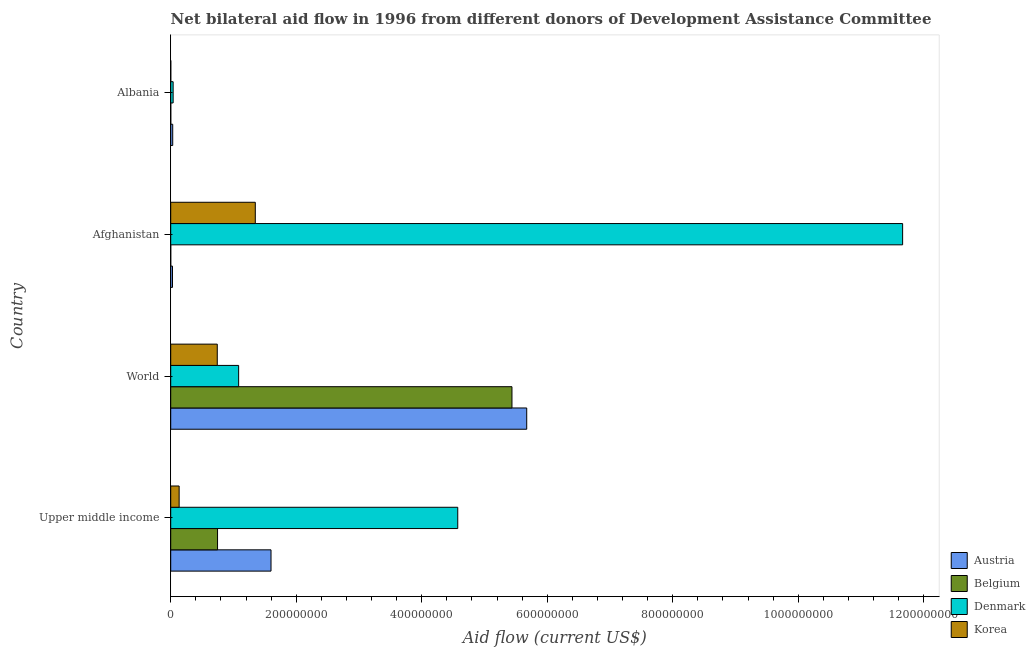How many groups of bars are there?
Give a very brief answer. 4. How many bars are there on the 1st tick from the top?
Your answer should be very brief. 4. What is the label of the 1st group of bars from the top?
Your response must be concise. Albania. What is the amount of aid given by belgium in Albania?
Ensure brevity in your answer.  8.00e+04. Across all countries, what is the maximum amount of aid given by belgium?
Your answer should be compact. 5.44e+08. Across all countries, what is the minimum amount of aid given by denmark?
Your answer should be very brief. 3.85e+06. In which country was the amount of aid given by denmark maximum?
Provide a succinct answer. Afghanistan. In which country was the amount of aid given by belgium minimum?
Your response must be concise. Afghanistan. What is the total amount of aid given by austria in the graph?
Your response must be concise. 7.33e+08. What is the difference between the amount of aid given by belgium in Afghanistan and that in Upper middle income?
Offer a terse response. -7.46e+07. What is the difference between the amount of aid given by denmark in World and the amount of aid given by korea in Afghanistan?
Provide a short and direct response. -2.66e+07. What is the average amount of aid given by belgium per country?
Provide a short and direct response. 1.55e+08. What is the difference between the amount of aid given by denmark and amount of aid given by belgium in Albania?
Offer a very short reply. 3.77e+06. In how many countries, is the amount of aid given by belgium greater than 160000000 US$?
Provide a short and direct response. 1. What is the ratio of the amount of aid given by austria in Albania to that in World?
Your answer should be compact. 0.01. What is the difference between the highest and the second highest amount of aid given by belgium?
Provide a short and direct response. 4.69e+08. What is the difference between the highest and the lowest amount of aid given by austria?
Ensure brevity in your answer.  5.64e+08. In how many countries, is the amount of aid given by denmark greater than the average amount of aid given by denmark taken over all countries?
Provide a succinct answer. 2. Is it the case that in every country, the sum of the amount of aid given by austria and amount of aid given by belgium is greater than the amount of aid given by denmark?
Your answer should be compact. No. Are all the bars in the graph horizontal?
Ensure brevity in your answer.  Yes. Are the values on the major ticks of X-axis written in scientific E-notation?
Keep it short and to the point. No. Does the graph contain any zero values?
Give a very brief answer. No. Does the graph contain grids?
Make the answer very short. No. Where does the legend appear in the graph?
Your response must be concise. Bottom right. What is the title of the graph?
Ensure brevity in your answer.  Net bilateral aid flow in 1996 from different donors of Development Assistance Committee. Does "Norway" appear as one of the legend labels in the graph?
Offer a terse response. No. What is the label or title of the X-axis?
Offer a terse response. Aid flow (current US$). What is the label or title of the Y-axis?
Provide a succinct answer. Country. What is the Aid flow (current US$) of Austria in Upper middle income?
Offer a terse response. 1.60e+08. What is the Aid flow (current US$) in Belgium in Upper middle income?
Keep it short and to the point. 7.46e+07. What is the Aid flow (current US$) of Denmark in Upper middle income?
Ensure brevity in your answer.  4.57e+08. What is the Aid flow (current US$) of Korea in Upper middle income?
Make the answer very short. 1.34e+07. What is the Aid flow (current US$) of Austria in World?
Offer a very short reply. 5.67e+08. What is the Aid flow (current US$) of Belgium in World?
Your answer should be very brief. 5.44e+08. What is the Aid flow (current US$) in Denmark in World?
Offer a terse response. 1.08e+08. What is the Aid flow (current US$) of Korea in World?
Keep it short and to the point. 7.42e+07. What is the Aid flow (current US$) of Austria in Afghanistan?
Provide a succinct answer. 2.85e+06. What is the Aid flow (current US$) of Denmark in Afghanistan?
Your response must be concise. 1.17e+09. What is the Aid flow (current US$) of Korea in Afghanistan?
Provide a succinct answer. 1.35e+08. What is the Aid flow (current US$) in Austria in Albania?
Offer a terse response. 3.19e+06. What is the Aid flow (current US$) of Belgium in Albania?
Offer a terse response. 8.00e+04. What is the Aid flow (current US$) in Denmark in Albania?
Your answer should be very brief. 3.85e+06. Across all countries, what is the maximum Aid flow (current US$) in Austria?
Ensure brevity in your answer.  5.67e+08. Across all countries, what is the maximum Aid flow (current US$) in Belgium?
Offer a terse response. 5.44e+08. Across all countries, what is the maximum Aid flow (current US$) in Denmark?
Your answer should be very brief. 1.17e+09. Across all countries, what is the maximum Aid flow (current US$) in Korea?
Provide a succinct answer. 1.35e+08. Across all countries, what is the minimum Aid flow (current US$) in Austria?
Offer a very short reply. 2.85e+06. Across all countries, what is the minimum Aid flow (current US$) in Belgium?
Provide a short and direct response. 10000. Across all countries, what is the minimum Aid flow (current US$) in Denmark?
Your answer should be compact. 3.85e+06. What is the total Aid flow (current US$) in Austria in the graph?
Provide a short and direct response. 7.33e+08. What is the total Aid flow (current US$) of Belgium in the graph?
Make the answer very short. 6.19e+08. What is the total Aid flow (current US$) in Denmark in the graph?
Offer a terse response. 1.74e+09. What is the total Aid flow (current US$) in Korea in the graph?
Your answer should be compact. 2.23e+08. What is the difference between the Aid flow (current US$) in Austria in Upper middle income and that in World?
Your answer should be compact. -4.08e+08. What is the difference between the Aid flow (current US$) in Belgium in Upper middle income and that in World?
Make the answer very short. -4.69e+08. What is the difference between the Aid flow (current US$) of Denmark in Upper middle income and that in World?
Your answer should be compact. 3.49e+08. What is the difference between the Aid flow (current US$) in Korea in Upper middle income and that in World?
Keep it short and to the point. -6.08e+07. What is the difference between the Aid flow (current US$) in Austria in Upper middle income and that in Afghanistan?
Your answer should be compact. 1.57e+08. What is the difference between the Aid flow (current US$) of Belgium in Upper middle income and that in Afghanistan?
Provide a short and direct response. 7.46e+07. What is the difference between the Aid flow (current US$) of Denmark in Upper middle income and that in Afghanistan?
Provide a short and direct response. -7.09e+08. What is the difference between the Aid flow (current US$) of Korea in Upper middle income and that in Afghanistan?
Keep it short and to the point. -1.21e+08. What is the difference between the Aid flow (current US$) of Austria in Upper middle income and that in Albania?
Provide a short and direct response. 1.57e+08. What is the difference between the Aid flow (current US$) in Belgium in Upper middle income and that in Albania?
Give a very brief answer. 7.46e+07. What is the difference between the Aid flow (current US$) in Denmark in Upper middle income and that in Albania?
Offer a very short reply. 4.54e+08. What is the difference between the Aid flow (current US$) of Korea in Upper middle income and that in Albania?
Your answer should be very brief. 1.33e+07. What is the difference between the Aid flow (current US$) in Austria in World and that in Afghanistan?
Make the answer very short. 5.64e+08. What is the difference between the Aid flow (current US$) of Belgium in World and that in Afghanistan?
Offer a terse response. 5.44e+08. What is the difference between the Aid flow (current US$) of Denmark in World and that in Afghanistan?
Your response must be concise. -1.06e+09. What is the difference between the Aid flow (current US$) in Korea in World and that in Afghanistan?
Provide a succinct answer. -6.06e+07. What is the difference between the Aid flow (current US$) in Austria in World and that in Albania?
Offer a terse response. 5.64e+08. What is the difference between the Aid flow (current US$) of Belgium in World and that in Albania?
Offer a very short reply. 5.44e+08. What is the difference between the Aid flow (current US$) in Denmark in World and that in Albania?
Give a very brief answer. 1.04e+08. What is the difference between the Aid flow (current US$) in Korea in World and that in Albania?
Make the answer very short. 7.41e+07. What is the difference between the Aid flow (current US$) in Austria in Afghanistan and that in Albania?
Your answer should be very brief. -3.40e+05. What is the difference between the Aid flow (current US$) of Belgium in Afghanistan and that in Albania?
Your answer should be very brief. -7.00e+04. What is the difference between the Aid flow (current US$) of Denmark in Afghanistan and that in Albania?
Give a very brief answer. 1.16e+09. What is the difference between the Aid flow (current US$) of Korea in Afghanistan and that in Albania?
Make the answer very short. 1.35e+08. What is the difference between the Aid flow (current US$) in Austria in Upper middle income and the Aid flow (current US$) in Belgium in World?
Give a very brief answer. -3.84e+08. What is the difference between the Aid flow (current US$) of Austria in Upper middle income and the Aid flow (current US$) of Denmark in World?
Make the answer very short. 5.16e+07. What is the difference between the Aid flow (current US$) of Austria in Upper middle income and the Aid flow (current US$) of Korea in World?
Your answer should be very brief. 8.56e+07. What is the difference between the Aid flow (current US$) in Belgium in Upper middle income and the Aid flow (current US$) in Denmark in World?
Keep it short and to the point. -3.36e+07. What is the difference between the Aid flow (current US$) of Denmark in Upper middle income and the Aid flow (current US$) of Korea in World?
Offer a very short reply. 3.83e+08. What is the difference between the Aid flow (current US$) in Austria in Upper middle income and the Aid flow (current US$) in Belgium in Afghanistan?
Your answer should be very brief. 1.60e+08. What is the difference between the Aid flow (current US$) in Austria in Upper middle income and the Aid flow (current US$) in Denmark in Afghanistan?
Provide a short and direct response. -1.01e+09. What is the difference between the Aid flow (current US$) in Austria in Upper middle income and the Aid flow (current US$) in Korea in Afghanistan?
Your answer should be compact. 2.50e+07. What is the difference between the Aid flow (current US$) of Belgium in Upper middle income and the Aid flow (current US$) of Denmark in Afghanistan?
Your answer should be very brief. -1.09e+09. What is the difference between the Aid flow (current US$) of Belgium in Upper middle income and the Aid flow (current US$) of Korea in Afghanistan?
Provide a short and direct response. -6.02e+07. What is the difference between the Aid flow (current US$) of Denmark in Upper middle income and the Aid flow (current US$) of Korea in Afghanistan?
Give a very brief answer. 3.23e+08. What is the difference between the Aid flow (current US$) of Austria in Upper middle income and the Aid flow (current US$) of Belgium in Albania?
Provide a succinct answer. 1.60e+08. What is the difference between the Aid flow (current US$) of Austria in Upper middle income and the Aid flow (current US$) of Denmark in Albania?
Make the answer very short. 1.56e+08. What is the difference between the Aid flow (current US$) of Austria in Upper middle income and the Aid flow (current US$) of Korea in Albania?
Offer a terse response. 1.60e+08. What is the difference between the Aid flow (current US$) of Belgium in Upper middle income and the Aid flow (current US$) of Denmark in Albania?
Your response must be concise. 7.08e+07. What is the difference between the Aid flow (current US$) of Belgium in Upper middle income and the Aid flow (current US$) of Korea in Albania?
Provide a short and direct response. 7.45e+07. What is the difference between the Aid flow (current US$) in Denmark in Upper middle income and the Aid flow (current US$) in Korea in Albania?
Keep it short and to the point. 4.57e+08. What is the difference between the Aid flow (current US$) of Austria in World and the Aid flow (current US$) of Belgium in Afghanistan?
Make the answer very short. 5.67e+08. What is the difference between the Aid flow (current US$) in Austria in World and the Aid flow (current US$) in Denmark in Afghanistan?
Provide a short and direct response. -5.99e+08. What is the difference between the Aid flow (current US$) of Austria in World and the Aid flow (current US$) of Korea in Afghanistan?
Your answer should be very brief. 4.33e+08. What is the difference between the Aid flow (current US$) of Belgium in World and the Aid flow (current US$) of Denmark in Afghanistan?
Keep it short and to the point. -6.23e+08. What is the difference between the Aid flow (current US$) in Belgium in World and the Aid flow (current US$) in Korea in Afghanistan?
Offer a very short reply. 4.09e+08. What is the difference between the Aid flow (current US$) of Denmark in World and the Aid flow (current US$) of Korea in Afghanistan?
Your answer should be compact. -2.66e+07. What is the difference between the Aid flow (current US$) of Austria in World and the Aid flow (current US$) of Belgium in Albania?
Give a very brief answer. 5.67e+08. What is the difference between the Aid flow (current US$) of Austria in World and the Aid flow (current US$) of Denmark in Albania?
Your response must be concise. 5.64e+08. What is the difference between the Aid flow (current US$) of Austria in World and the Aid flow (current US$) of Korea in Albania?
Your response must be concise. 5.67e+08. What is the difference between the Aid flow (current US$) in Belgium in World and the Aid flow (current US$) in Denmark in Albania?
Give a very brief answer. 5.40e+08. What is the difference between the Aid flow (current US$) in Belgium in World and the Aid flow (current US$) in Korea in Albania?
Ensure brevity in your answer.  5.44e+08. What is the difference between the Aid flow (current US$) of Denmark in World and the Aid flow (current US$) of Korea in Albania?
Provide a succinct answer. 1.08e+08. What is the difference between the Aid flow (current US$) in Austria in Afghanistan and the Aid flow (current US$) in Belgium in Albania?
Ensure brevity in your answer.  2.77e+06. What is the difference between the Aid flow (current US$) of Austria in Afghanistan and the Aid flow (current US$) of Denmark in Albania?
Ensure brevity in your answer.  -1.00e+06. What is the difference between the Aid flow (current US$) of Austria in Afghanistan and the Aid flow (current US$) of Korea in Albania?
Your response must be concise. 2.74e+06. What is the difference between the Aid flow (current US$) in Belgium in Afghanistan and the Aid flow (current US$) in Denmark in Albania?
Make the answer very short. -3.84e+06. What is the difference between the Aid flow (current US$) of Belgium in Afghanistan and the Aid flow (current US$) of Korea in Albania?
Offer a terse response. -1.00e+05. What is the difference between the Aid flow (current US$) in Denmark in Afghanistan and the Aid flow (current US$) in Korea in Albania?
Provide a succinct answer. 1.17e+09. What is the average Aid flow (current US$) of Austria per country?
Keep it short and to the point. 1.83e+08. What is the average Aid flow (current US$) of Belgium per country?
Keep it short and to the point. 1.55e+08. What is the average Aid flow (current US$) in Denmark per country?
Offer a very short reply. 4.34e+08. What is the average Aid flow (current US$) in Korea per country?
Give a very brief answer. 5.56e+07. What is the difference between the Aid flow (current US$) of Austria and Aid flow (current US$) of Belgium in Upper middle income?
Your answer should be compact. 8.52e+07. What is the difference between the Aid flow (current US$) in Austria and Aid flow (current US$) in Denmark in Upper middle income?
Keep it short and to the point. -2.98e+08. What is the difference between the Aid flow (current US$) of Austria and Aid flow (current US$) of Korea in Upper middle income?
Make the answer very short. 1.46e+08. What is the difference between the Aid flow (current US$) in Belgium and Aid flow (current US$) in Denmark in Upper middle income?
Your answer should be compact. -3.83e+08. What is the difference between the Aid flow (current US$) of Belgium and Aid flow (current US$) of Korea in Upper middle income?
Ensure brevity in your answer.  6.12e+07. What is the difference between the Aid flow (current US$) in Denmark and Aid flow (current US$) in Korea in Upper middle income?
Offer a terse response. 4.44e+08. What is the difference between the Aid flow (current US$) in Austria and Aid flow (current US$) in Belgium in World?
Make the answer very short. 2.35e+07. What is the difference between the Aid flow (current US$) in Austria and Aid flow (current US$) in Denmark in World?
Your answer should be very brief. 4.59e+08. What is the difference between the Aid flow (current US$) of Austria and Aid flow (current US$) of Korea in World?
Your answer should be compact. 4.93e+08. What is the difference between the Aid flow (current US$) of Belgium and Aid flow (current US$) of Denmark in World?
Ensure brevity in your answer.  4.36e+08. What is the difference between the Aid flow (current US$) in Belgium and Aid flow (current US$) in Korea in World?
Give a very brief answer. 4.70e+08. What is the difference between the Aid flow (current US$) in Denmark and Aid flow (current US$) in Korea in World?
Give a very brief answer. 3.40e+07. What is the difference between the Aid flow (current US$) of Austria and Aid flow (current US$) of Belgium in Afghanistan?
Provide a succinct answer. 2.84e+06. What is the difference between the Aid flow (current US$) in Austria and Aid flow (current US$) in Denmark in Afghanistan?
Offer a terse response. -1.16e+09. What is the difference between the Aid flow (current US$) of Austria and Aid flow (current US$) of Korea in Afghanistan?
Your answer should be compact. -1.32e+08. What is the difference between the Aid flow (current US$) of Belgium and Aid flow (current US$) of Denmark in Afghanistan?
Make the answer very short. -1.17e+09. What is the difference between the Aid flow (current US$) of Belgium and Aid flow (current US$) of Korea in Afghanistan?
Offer a very short reply. -1.35e+08. What is the difference between the Aid flow (current US$) in Denmark and Aid flow (current US$) in Korea in Afghanistan?
Ensure brevity in your answer.  1.03e+09. What is the difference between the Aid flow (current US$) of Austria and Aid flow (current US$) of Belgium in Albania?
Give a very brief answer. 3.11e+06. What is the difference between the Aid flow (current US$) in Austria and Aid flow (current US$) in Denmark in Albania?
Your response must be concise. -6.60e+05. What is the difference between the Aid flow (current US$) in Austria and Aid flow (current US$) in Korea in Albania?
Your answer should be compact. 3.08e+06. What is the difference between the Aid flow (current US$) of Belgium and Aid flow (current US$) of Denmark in Albania?
Your response must be concise. -3.77e+06. What is the difference between the Aid flow (current US$) in Denmark and Aid flow (current US$) in Korea in Albania?
Your answer should be very brief. 3.74e+06. What is the ratio of the Aid flow (current US$) of Austria in Upper middle income to that in World?
Provide a succinct answer. 0.28. What is the ratio of the Aid flow (current US$) of Belgium in Upper middle income to that in World?
Provide a short and direct response. 0.14. What is the ratio of the Aid flow (current US$) in Denmark in Upper middle income to that in World?
Make the answer very short. 4.23. What is the ratio of the Aid flow (current US$) in Korea in Upper middle income to that in World?
Provide a short and direct response. 0.18. What is the ratio of the Aid flow (current US$) of Austria in Upper middle income to that in Afghanistan?
Give a very brief answer. 56.08. What is the ratio of the Aid flow (current US$) in Belgium in Upper middle income to that in Afghanistan?
Offer a very short reply. 7463. What is the ratio of the Aid flow (current US$) of Denmark in Upper middle income to that in Afghanistan?
Make the answer very short. 0.39. What is the ratio of the Aid flow (current US$) of Korea in Upper middle income to that in Afghanistan?
Provide a short and direct response. 0.1. What is the ratio of the Aid flow (current US$) in Austria in Upper middle income to that in Albania?
Make the answer very short. 50.1. What is the ratio of the Aid flow (current US$) in Belgium in Upper middle income to that in Albania?
Your answer should be compact. 932.88. What is the ratio of the Aid flow (current US$) of Denmark in Upper middle income to that in Albania?
Provide a short and direct response. 118.82. What is the ratio of the Aid flow (current US$) in Korea in Upper middle income to that in Albania?
Keep it short and to the point. 122.09. What is the ratio of the Aid flow (current US$) of Austria in World to that in Afghanistan?
Give a very brief answer. 199.07. What is the ratio of the Aid flow (current US$) in Belgium in World to that in Afghanistan?
Keep it short and to the point. 5.44e+04. What is the ratio of the Aid flow (current US$) in Denmark in World to that in Afghanistan?
Your answer should be very brief. 0.09. What is the ratio of the Aid flow (current US$) in Korea in World to that in Afghanistan?
Your answer should be very brief. 0.55. What is the ratio of the Aid flow (current US$) of Austria in World to that in Albania?
Offer a very short reply. 177.85. What is the ratio of the Aid flow (current US$) of Belgium in World to that in Albania?
Provide a short and direct response. 6798.12. What is the ratio of the Aid flow (current US$) in Denmark in World to that in Albania?
Your answer should be very brief. 28.11. What is the ratio of the Aid flow (current US$) of Korea in World to that in Albania?
Your answer should be very brief. 674.45. What is the ratio of the Aid flow (current US$) in Austria in Afghanistan to that in Albania?
Make the answer very short. 0.89. What is the ratio of the Aid flow (current US$) of Belgium in Afghanistan to that in Albania?
Your answer should be very brief. 0.12. What is the ratio of the Aid flow (current US$) of Denmark in Afghanistan to that in Albania?
Provide a succinct answer. 302.97. What is the ratio of the Aid flow (current US$) in Korea in Afghanistan to that in Albania?
Offer a very short reply. 1225.45. What is the difference between the highest and the second highest Aid flow (current US$) in Austria?
Your answer should be compact. 4.08e+08. What is the difference between the highest and the second highest Aid flow (current US$) in Belgium?
Your answer should be very brief. 4.69e+08. What is the difference between the highest and the second highest Aid flow (current US$) of Denmark?
Keep it short and to the point. 7.09e+08. What is the difference between the highest and the second highest Aid flow (current US$) in Korea?
Ensure brevity in your answer.  6.06e+07. What is the difference between the highest and the lowest Aid flow (current US$) in Austria?
Your answer should be very brief. 5.64e+08. What is the difference between the highest and the lowest Aid flow (current US$) of Belgium?
Provide a short and direct response. 5.44e+08. What is the difference between the highest and the lowest Aid flow (current US$) of Denmark?
Give a very brief answer. 1.16e+09. What is the difference between the highest and the lowest Aid flow (current US$) of Korea?
Offer a terse response. 1.35e+08. 